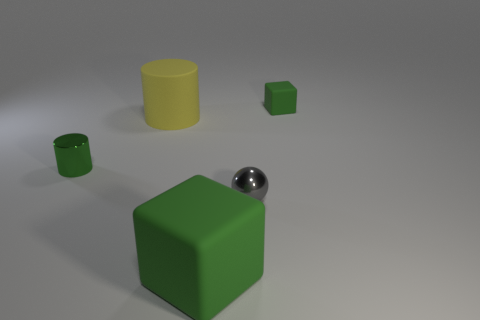Is the tiny gray object the same shape as the large green thing?
Provide a short and direct response. No. How many matte things are either blocks or big green objects?
Provide a succinct answer. 2. What is the material of the cylinder that is the same color as the tiny matte block?
Ensure brevity in your answer.  Metal. Do the yellow matte object and the green shiny thing have the same size?
Offer a very short reply. No. How many objects are either metallic objects or tiny green objects in front of the large yellow matte cylinder?
Make the answer very short. 2. There is a block that is the same size as the green metal cylinder; what is it made of?
Keep it short and to the point. Rubber. What is the thing that is behind the green shiny cylinder and in front of the small green block made of?
Provide a succinct answer. Rubber. Is there a matte object that is to the left of the cube in front of the tiny green cylinder?
Offer a very short reply. Yes. There is a green object that is behind the shiny ball and in front of the tiny green block; what is its size?
Keep it short and to the point. Small. How many red things are metallic objects or big blocks?
Provide a short and direct response. 0. 